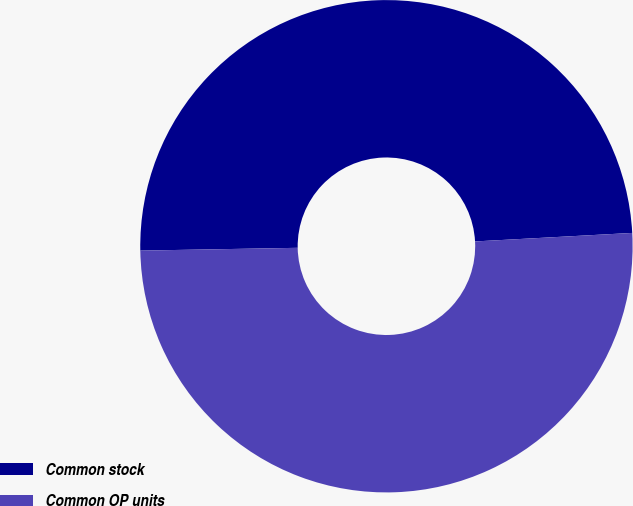<chart> <loc_0><loc_0><loc_500><loc_500><pie_chart><fcel>Common stock<fcel>Common OP units<nl><fcel>49.42%<fcel>50.58%<nl></chart> 